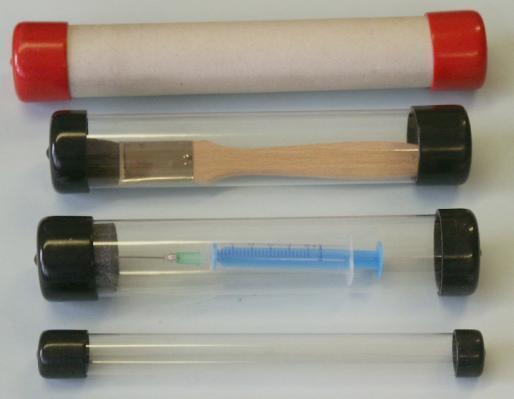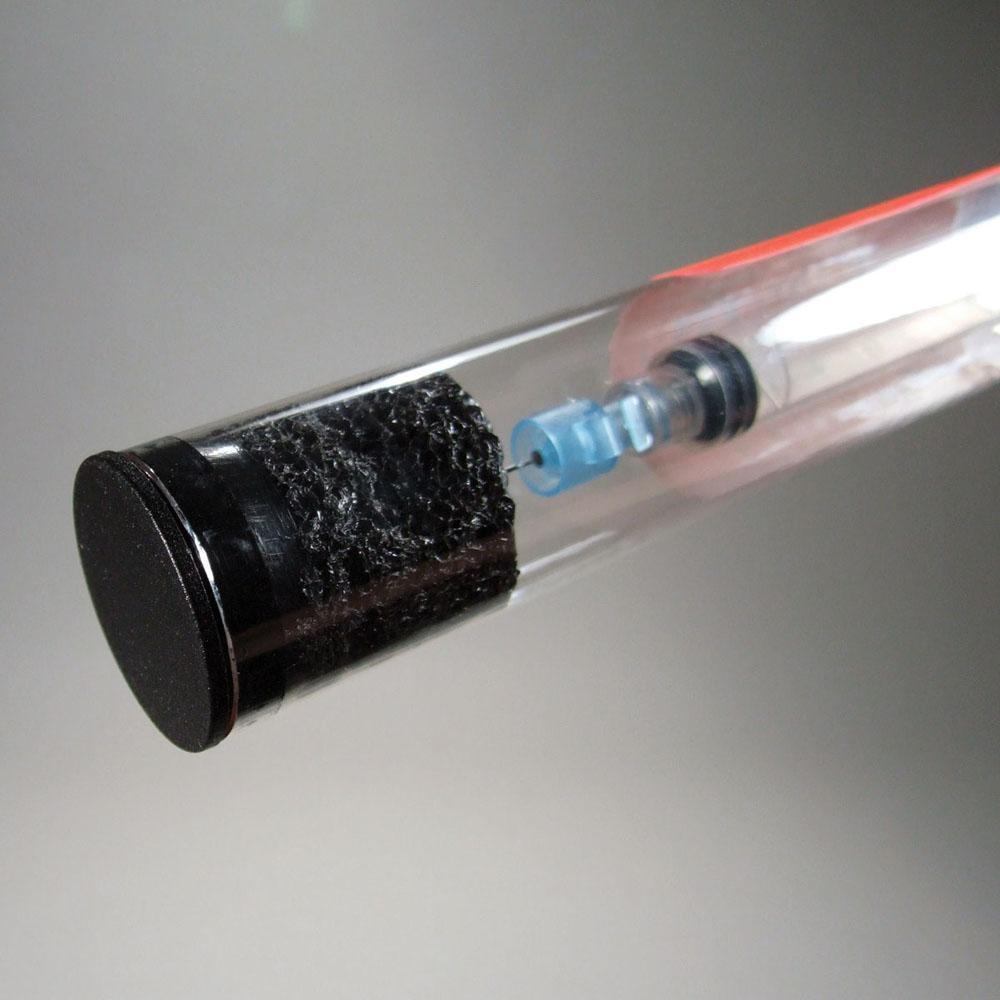The first image is the image on the left, the second image is the image on the right. Analyze the images presented: Is the assertion "There are two canisters in the right image." valid? Answer yes or no. No. The first image is the image on the left, the second image is the image on the right. For the images displayed, is the sentence "An image shows at least three tubes with caps on the ends." factually correct? Answer yes or no. Yes. 